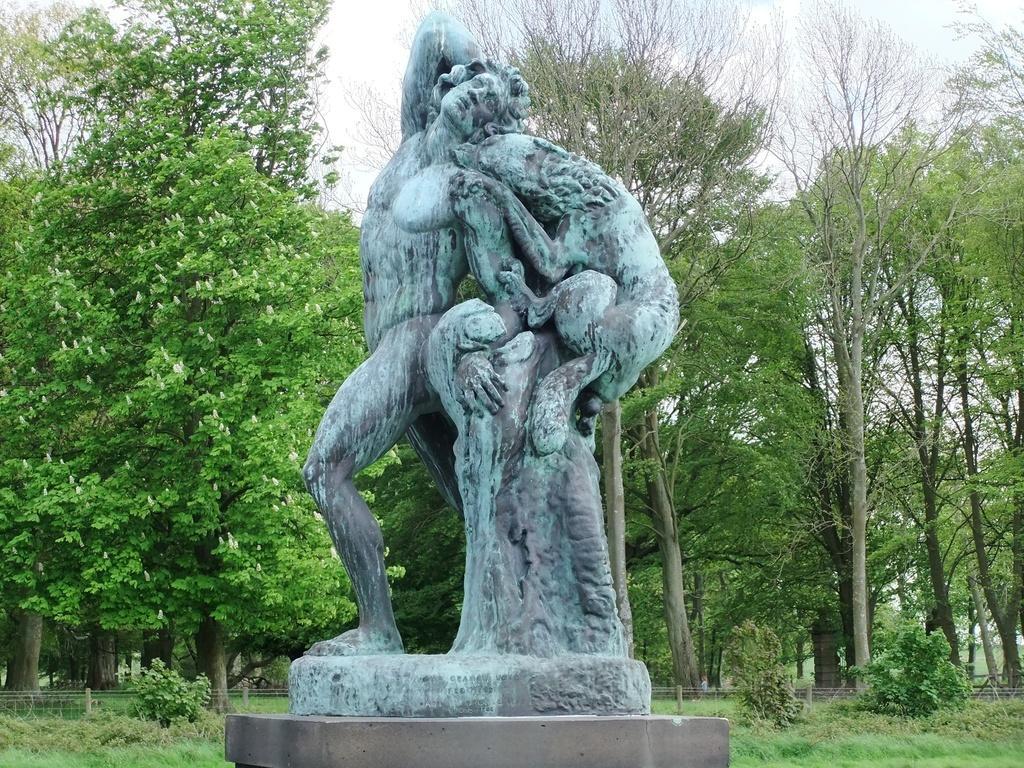Describe this image in one or two sentences. In the center of the image there is a statue. In the background we can see trees, grass, plants and sky. 